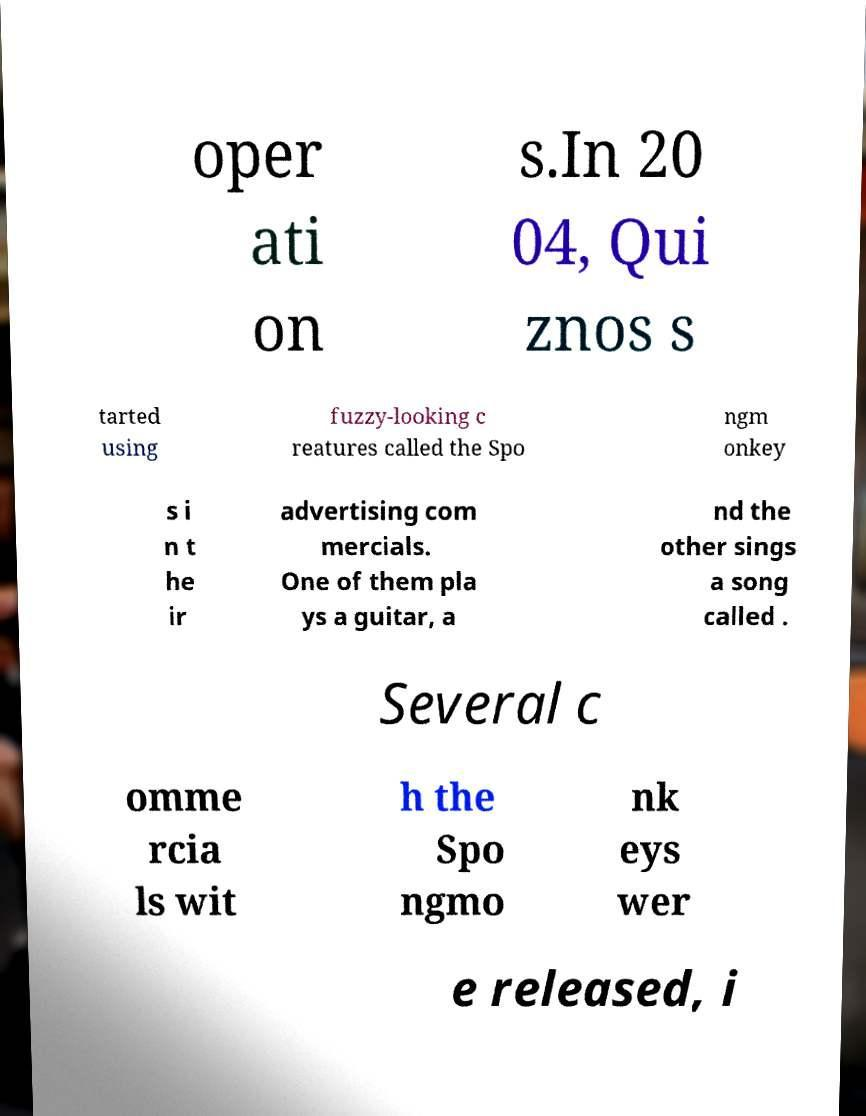For documentation purposes, I need the text within this image transcribed. Could you provide that? oper ati on s.In 20 04, Qui znos s tarted using fuzzy-looking c reatures called the Spo ngm onkey s i n t he ir advertising com mercials. One of them pla ys a guitar, a nd the other sings a song called . Several c omme rcia ls wit h the Spo ngmo nk eys wer e released, i 